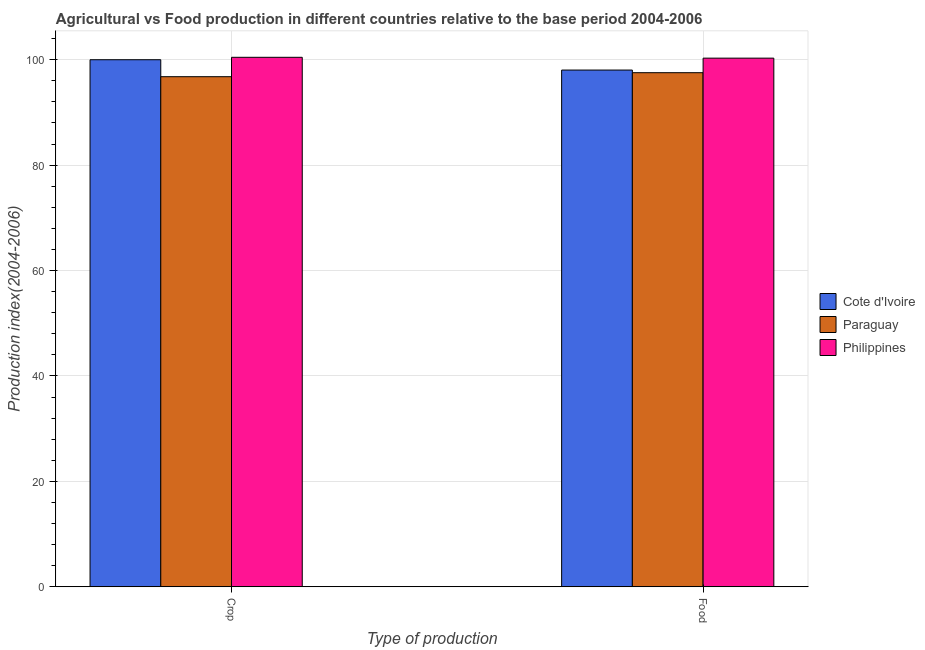What is the label of the 2nd group of bars from the left?
Offer a very short reply. Food. What is the crop production index in Cote d'Ivoire?
Your answer should be very brief. 99.99. Across all countries, what is the maximum crop production index?
Ensure brevity in your answer.  100.45. Across all countries, what is the minimum food production index?
Offer a terse response. 97.53. In which country was the crop production index minimum?
Your answer should be very brief. Paraguay. What is the total crop production index in the graph?
Ensure brevity in your answer.  297.21. What is the difference between the food production index in Philippines and that in Cote d'Ivoire?
Make the answer very short. 2.26. What is the difference between the crop production index in Cote d'Ivoire and the food production index in Philippines?
Ensure brevity in your answer.  -0.3. What is the average crop production index per country?
Make the answer very short. 99.07. What is the difference between the crop production index and food production index in Cote d'Ivoire?
Give a very brief answer. 1.96. What is the ratio of the crop production index in Paraguay to that in Cote d'Ivoire?
Your answer should be very brief. 0.97. What does the 1st bar from the left in Food represents?
Your response must be concise. Cote d'Ivoire. What does the 2nd bar from the right in Crop represents?
Give a very brief answer. Paraguay. How many bars are there?
Keep it short and to the point. 6. Are all the bars in the graph horizontal?
Your response must be concise. No. How many countries are there in the graph?
Offer a terse response. 3. Are the values on the major ticks of Y-axis written in scientific E-notation?
Your answer should be very brief. No. Does the graph contain any zero values?
Ensure brevity in your answer.  No. Does the graph contain grids?
Your answer should be very brief. Yes. What is the title of the graph?
Provide a short and direct response. Agricultural vs Food production in different countries relative to the base period 2004-2006. What is the label or title of the X-axis?
Offer a terse response. Type of production. What is the label or title of the Y-axis?
Make the answer very short. Production index(2004-2006). What is the Production index(2004-2006) in Cote d'Ivoire in Crop?
Your answer should be very brief. 99.99. What is the Production index(2004-2006) in Paraguay in Crop?
Offer a terse response. 96.77. What is the Production index(2004-2006) in Philippines in Crop?
Provide a succinct answer. 100.45. What is the Production index(2004-2006) of Cote d'Ivoire in Food?
Your response must be concise. 98.03. What is the Production index(2004-2006) in Paraguay in Food?
Provide a succinct answer. 97.53. What is the Production index(2004-2006) in Philippines in Food?
Offer a terse response. 100.29. Across all Type of production, what is the maximum Production index(2004-2006) of Cote d'Ivoire?
Keep it short and to the point. 99.99. Across all Type of production, what is the maximum Production index(2004-2006) in Paraguay?
Keep it short and to the point. 97.53. Across all Type of production, what is the maximum Production index(2004-2006) in Philippines?
Keep it short and to the point. 100.45. Across all Type of production, what is the minimum Production index(2004-2006) of Cote d'Ivoire?
Give a very brief answer. 98.03. Across all Type of production, what is the minimum Production index(2004-2006) of Paraguay?
Provide a short and direct response. 96.77. Across all Type of production, what is the minimum Production index(2004-2006) in Philippines?
Keep it short and to the point. 100.29. What is the total Production index(2004-2006) in Cote d'Ivoire in the graph?
Your answer should be very brief. 198.02. What is the total Production index(2004-2006) of Paraguay in the graph?
Your response must be concise. 194.3. What is the total Production index(2004-2006) in Philippines in the graph?
Make the answer very short. 200.74. What is the difference between the Production index(2004-2006) in Cote d'Ivoire in Crop and that in Food?
Provide a short and direct response. 1.96. What is the difference between the Production index(2004-2006) in Paraguay in Crop and that in Food?
Offer a very short reply. -0.76. What is the difference between the Production index(2004-2006) in Philippines in Crop and that in Food?
Keep it short and to the point. 0.16. What is the difference between the Production index(2004-2006) of Cote d'Ivoire in Crop and the Production index(2004-2006) of Paraguay in Food?
Make the answer very short. 2.46. What is the difference between the Production index(2004-2006) in Cote d'Ivoire in Crop and the Production index(2004-2006) in Philippines in Food?
Your response must be concise. -0.3. What is the difference between the Production index(2004-2006) in Paraguay in Crop and the Production index(2004-2006) in Philippines in Food?
Your response must be concise. -3.52. What is the average Production index(2004-2006) in Cote d'Ivoire per Type of production?
Provide a succinct answer. 99.01. What is the average Production index(2004-2006) of Paraguay per Type of production?
Offer a terse response. 97.15. What is the average Production index(2004-2006) of Philippines per Type of production?
Give a very brief answer. 100.37. What is the difference between the Production index(2004-2006) of Cote d'Ivoire and Production index(2004-2006) of Paraguay in Crop?
Your response must be concise. 3.22. What is the difference between the Production index(2004-2006) of Cote d'Ivoire and Production index(2004-2006) of Philippines in Crop?
Your response must be concise. -0.46. What is the difference between the Production index(2004-2006) in Paraguay and Production index(2004-2006) in Philippines in Crop?
Your answer should be compact. -3.68. What is the difference between the Production index(2004-2006) of Cote d'Ivoire and Production index(2004-2006) of Philippines in Food?
Provide a succinct answer. -2.26. What is the difference between the Production index(2004-2006) of Paraguay and Production index(2004-2006) of Philippines in Food?
Ensure brevity in your answer.  -2.76. What is the difference between the highest and the second highest Production index(2004-2006) of Cote d'Ivoire?
Ensure brevity in your answer.  1.96. What is the difference between the highest and the second highest Production index(2004-2006) in Paraguay?
Your response must be concise. 0.76. What is the difference between the highest and the second highest Production index(2004-2006) of Philippines?
Offer a terse response. 0.16. What is the difference between the highest and the lowest Production index(2004-2006) of Cote d'Ivoire?
Ensure brevity in your answer.  1.96. What is the difference between the highest and the lowest Production index(2004-2006) of Paraguay?
Your answer should be very brief. 0.76. What is the difference between the highest and the lowest Production index(2004-2006) of Philippines?
Give a very brief answer. 0.16. 